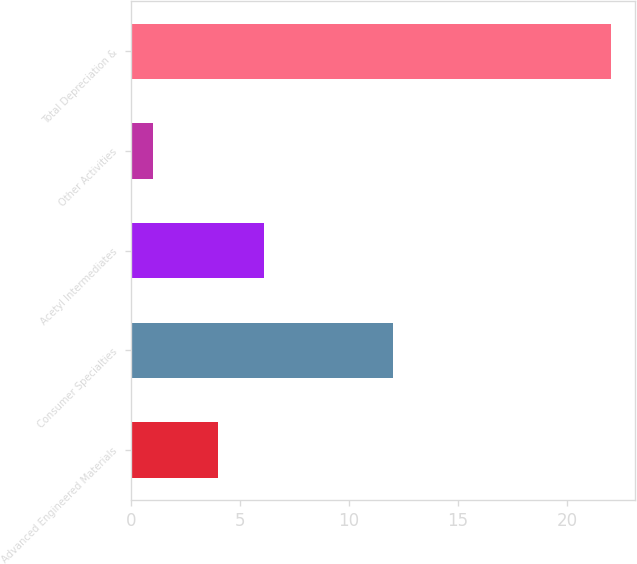<chart> <loc_0><loc_0><loc_500><loc_500><bar_chart><fcel>Advanced Engineered Materials<fcel>Consumer Specialties<fcel>Acetyl Intermediates<fcel>Other Activities<fcel>Total Depreciation &<nl><fcel>4<fcel>12<fcel>6.1<fcel>1<fcel>22<nl></chart> 